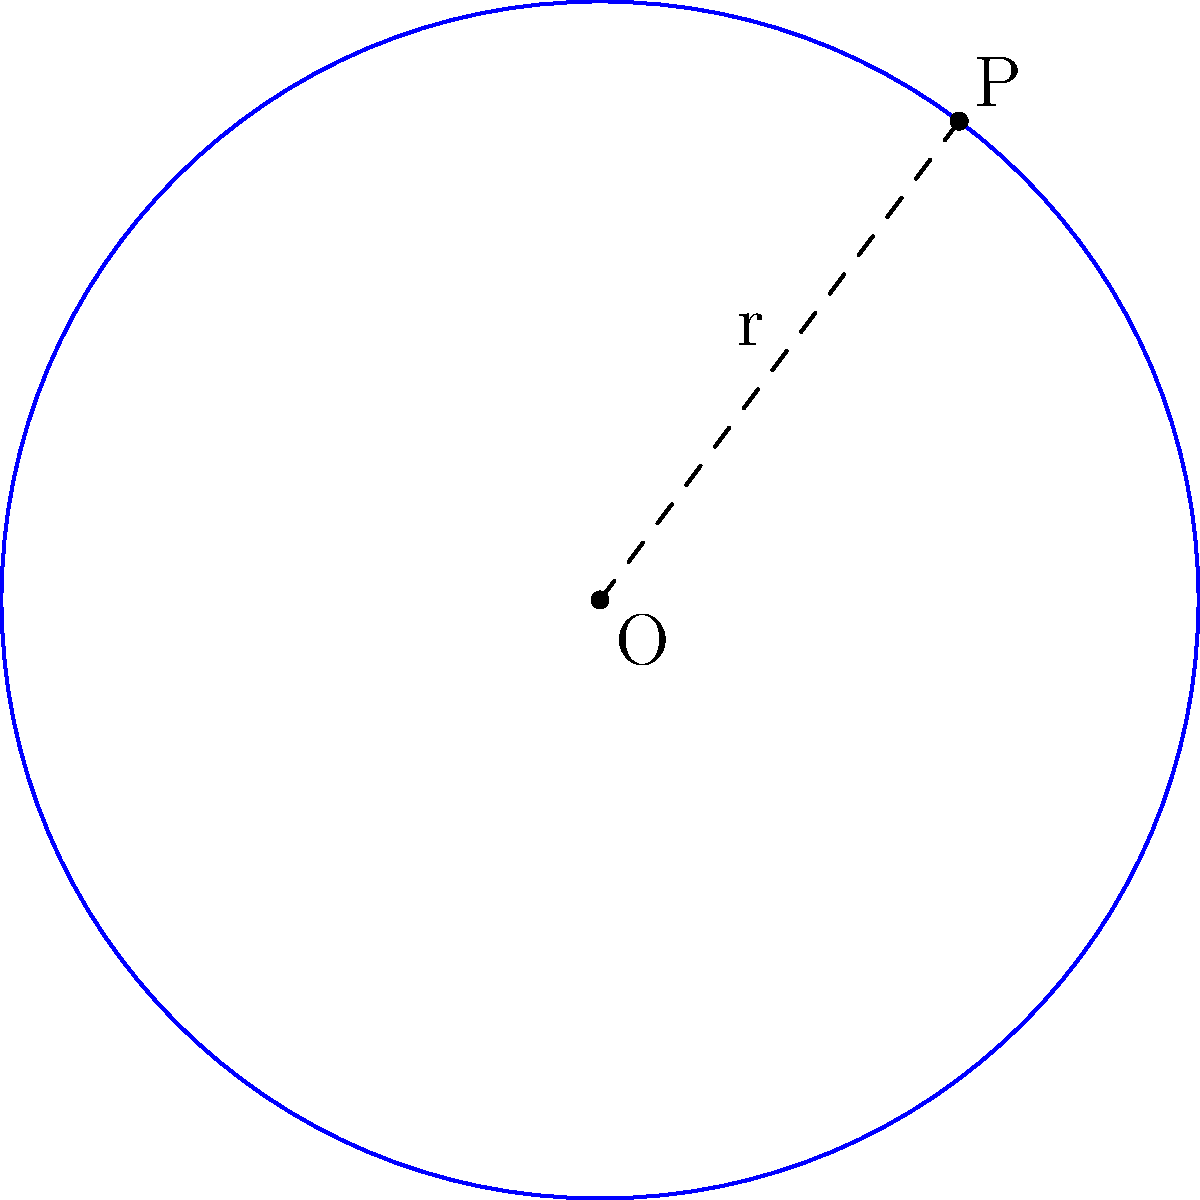As an aspiring actuary, you're tasked with determining the equation of a circle given its center and a point on the circumference. The center of the circle is at point O(2,3), and point P(5,7) lies on the circumference. Find the equation of this circle in standard form: $$(x-h)^2 + (y-k)^2 = r^2$$ Let's approach this step-by-step:

1) We know the center of the circle is at (2,3), so h = 2 and k = 3.

2) To find r, we need to calculate the distance between O(2,3) and P(5,7):

   $r = \sqrt{(x_P - x_O)^2 + (y_P - y_O)^2}$
   $r = \sqrt{(5 - 2)^2 + (7 - 3)^2}$
   $r = \sqrt{3^2 + 4^2}$
   $r = \sqrt{9 + 16}$
   $r = \sqrt{25}$
   $r = 5$

3) Now we have all the components to write the equation:

   $(x - h)^2 + (y - k)^2 = r^2$
   $(x - 2)^2 + (y - 3)^2 = 5^2$

4) Simplify:

   $(x - 2)^2 + (y - 3)^2 = 25$

This is the equation of the circle in standard form.
Answer: $(x - 2)^2 + (y - 3)^2 = 25$ 